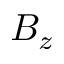<formula> <loc_0><loc_0><loc_500><loc_500>B _ { z }</formula> 